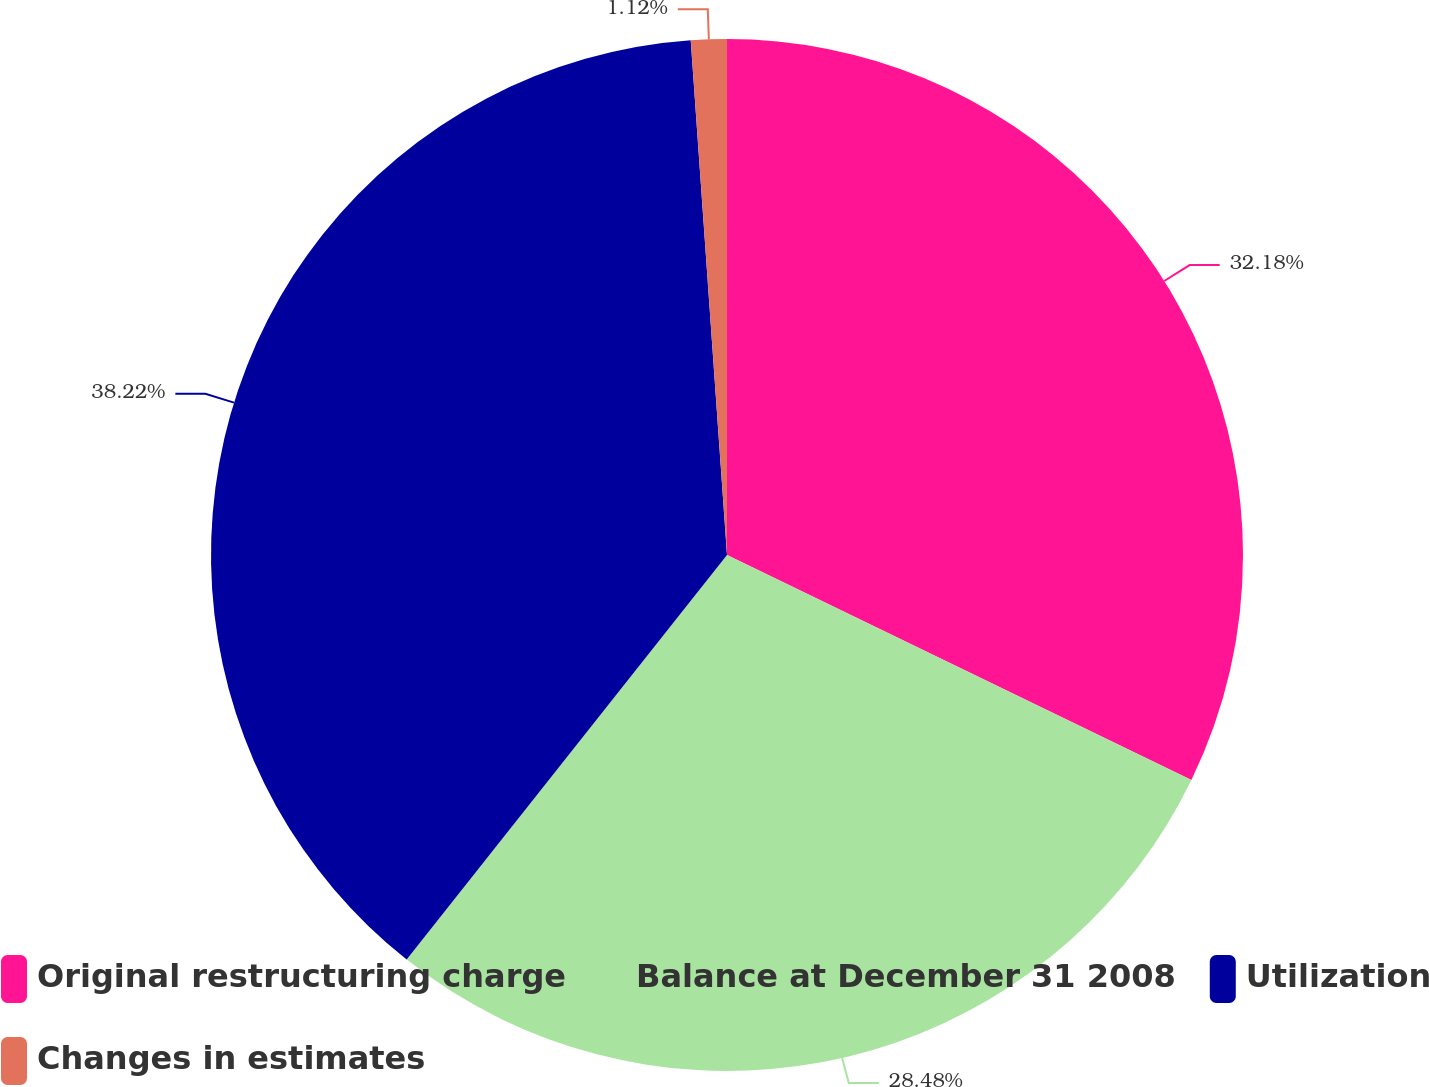Convert chart to OTSL. <chart><loc_0><loc_0><loc_500><loc_500><pie_chart><fcel>Original restructuring charge<fcel>Balance at December 31 2008<fcel>Utilization<fcel>Changes in estimates<nl><fcel>32.18%<fcel>28.48%<fcel>38.22%<fcel>1.12%<nl></chart> 